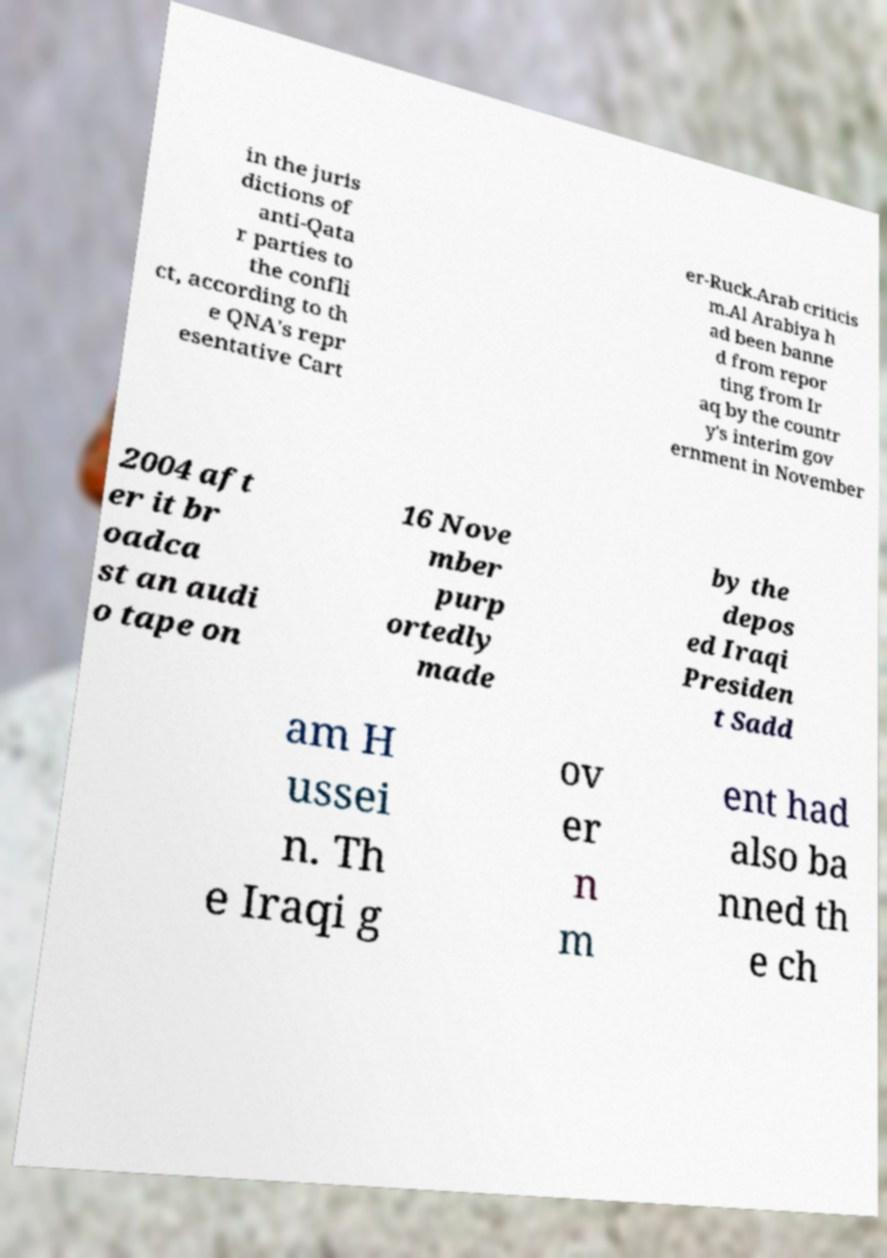Please identify and transcribe the text found in this image. in the juris dictions of anti-Qata r parties to the confli ct, according to th e QNA's repr esentative Cart er-Ruck.Arab criticis m.Al Arabiya h ad been banne d from repor ting from Ir aq by the countr y's interim gov ernment in November 2004 aft er it br oadca st an audi o tape on 16 Nove mber purp ortedly made by the depos ed Iraqi Presiden t Sadd am H ussei n. Th e Iraqi g ov er n m ent had also ba nned th e ch 